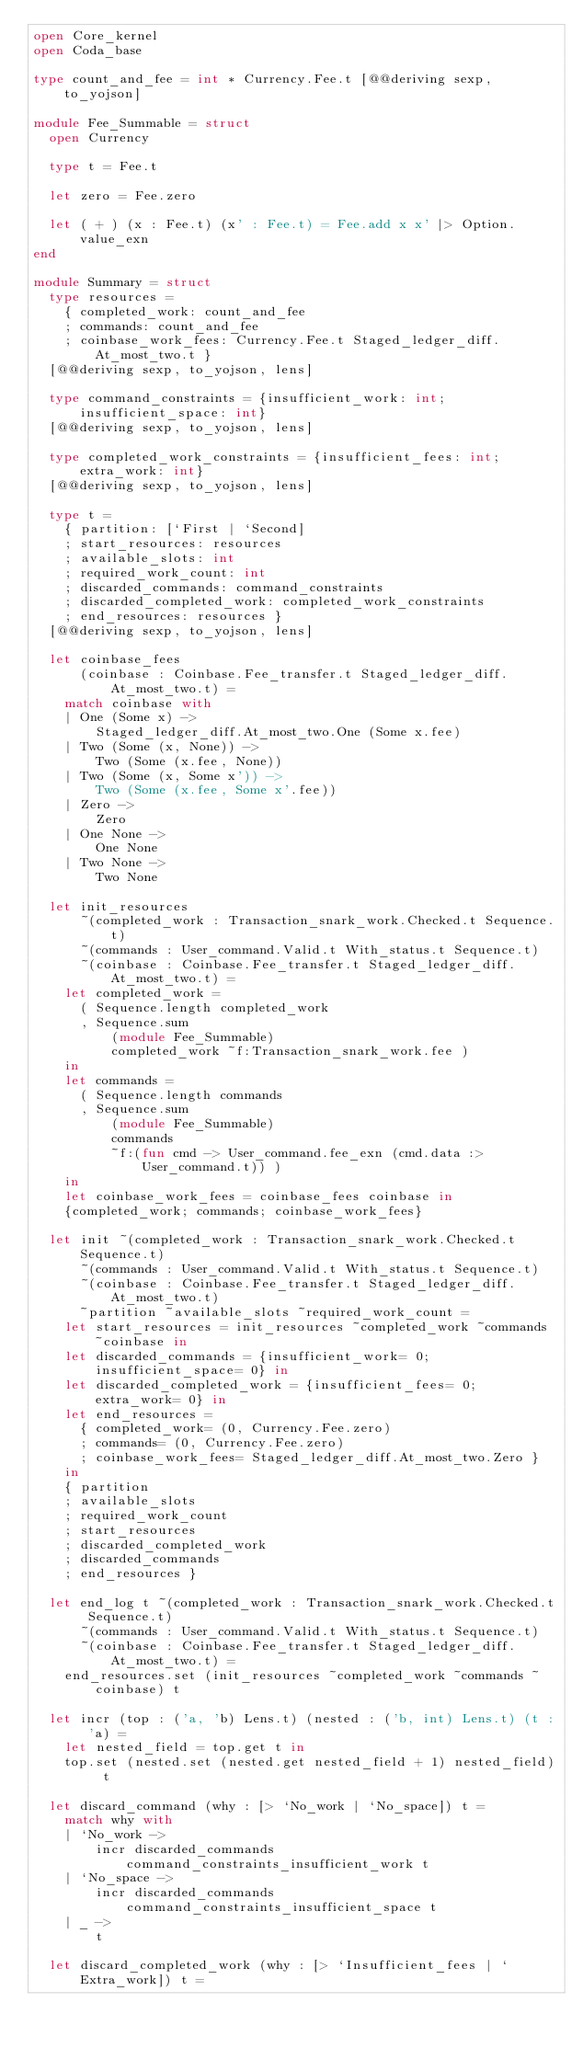<code> <loc_0><loc_0><loc_500><loc_500><_OCaml_>open Core_kernel
open Coda_base

type count_and_fee = int * Currency.Fee.t [@@deriving sexp, to_yojson]

module Fee_Summable = struct
  open Currency

  type t = Fee.t

  let zero = Fee.zero

  let ( + ) (x : Fee.t) (x' : Fee.t) = Fee.add x x' |> Option.value_exn
end

module Summary = struct
  type resources =
    { completed_work: count_and_fee
    ; commands: count_and_fee
    ; coinbase_work_fees: Currency.Fee.t Staged_ledger_diff.At_most_two.t }
  [@@deriving sexp, to_yojson, lens]

  type command_constraints = {insufficient_work: int; insufficient_space: int}
  [@@deriving sexp, to_yojson, lens]

  type completed_work_constraints = {insufficient_fees: int; extra_work: int}
  [@@deriving sexp, to_yojson, lens]

  type t =
    { partition: [`First | `Second]
    ; start_resources: resources
    ; available_slots: int
    ; required_work_count: int
    ; discarded_commands: command_constraints
    ; discarded_completed_work: completed_work_constraints
    ; end_resources: resources }
  [@@deriving sexp, to_yojson, lens]

  let coinbase_fees
      (coinbase : Coinbase.Fee_transfer.t Staged_ledger_diff.At_most_two.t) =
    match coinbase with
    | One (Some x) ->
        Staged_ledger_diff.At_most_two.One (Some x.fee)
    | Two (Some (x, None)) ->
        Two (Some (x.fee, None))
    | Two (Some (x, Some x')) ->
        Two (Some (x.fee, Some x'.fee))
    | Zero ->
        Zero
    | One None ->
        One None
    | Two None ->
        Two None

  let init_resources
      ~(completed_work : Transaction_snark_work.Checked.t Sequence.t)
      ~(commands : User_command.Valid.t With_status.t Sequence.t)
      ~(coinbase : Coinbase.Fee_transfer.t Staged_ledger_diff.At_most_two.t) =
    let completed_work =
      ( Sequence.length completed_work
      , Sequence.sum
          (module Fee_Summable)
          completed_work ~f:Transaction_snark_work.fee )
    in
    let commands =
      ( Sequence.length commands
      , Sequence.sum
          (module Fee_Summable)
          commands
          ~f:(fun cmd -> User_command.fee_exn (cmd.data :> User_command.t)) )
    in
    let coinbase_work_fees = coinbase_fees coinbase in
    {completed_work; commands; coinbase_work_fees}

  let init ~(completed_work : Transaction_snark_work.Checked.t Sequence.t)
      ~(commands : User_command.Valid.t With_status.t Sequence.t)
      ~(coinbase : Coinbase.Fee_transfer.t Staged_ledger_diff.At_most_two.t)
      ~partition ~available_slots ~required_work_count =
    let start_resources = init_resources ~completed_work ~commands ~coinbase in
    let discarded_commands = {insufficient_work= 0; insufficient_space= 0} in
    let discarded_completed_work = {insufficient_fees= 0; extra_work= 0} in
    let end_resources =
      { completed_work= (0, Currency.Fee.zero)
      ; commands= (0, Currency.Fee.zero)
      ; coinbase_work_fees= Staged_ledger_diff.At_most_two.Zero }
    in
    { partition
    ; available_slots
    ; required_work_count
    ; start_resources
    ; discarded_completed_work
    ; discarded_commands
    ; end_resources }

  let end_log t ~(completed_work : Transaction_snark_work.Checked.t Sequence.t)
      ~(commands : User_command.Valid.t With_status.t Sequence.t)
      ~(coinbase : Coinbase.Fee_transfer.t Staged_ledger_diff.At_most_two.t) =
    end_resources.set (init_resources ~completed_work ~commands ~coinbase) t

  let incr (top : ('a, 'b) Lens.t) (nested : ('b, int) Lens.t) (t : 'a) =
    let nested_field = top.get t in
    top.set (nested.set (nested.get nested_field + 1) nested_field) t

  let discard_command (why : [> `No_work | `No_space]) t =
    match why with
    | `No_work ->
        incr discarded_commands command_constraints_insufficient_work t
    | `No_space ->
        incr discarded_commands command_constraints_insufficient_space t
    | _ ->
        t

  let discard_completed_work (why : [> `Insufficient_fees | `Extra_work]) t =</code> 